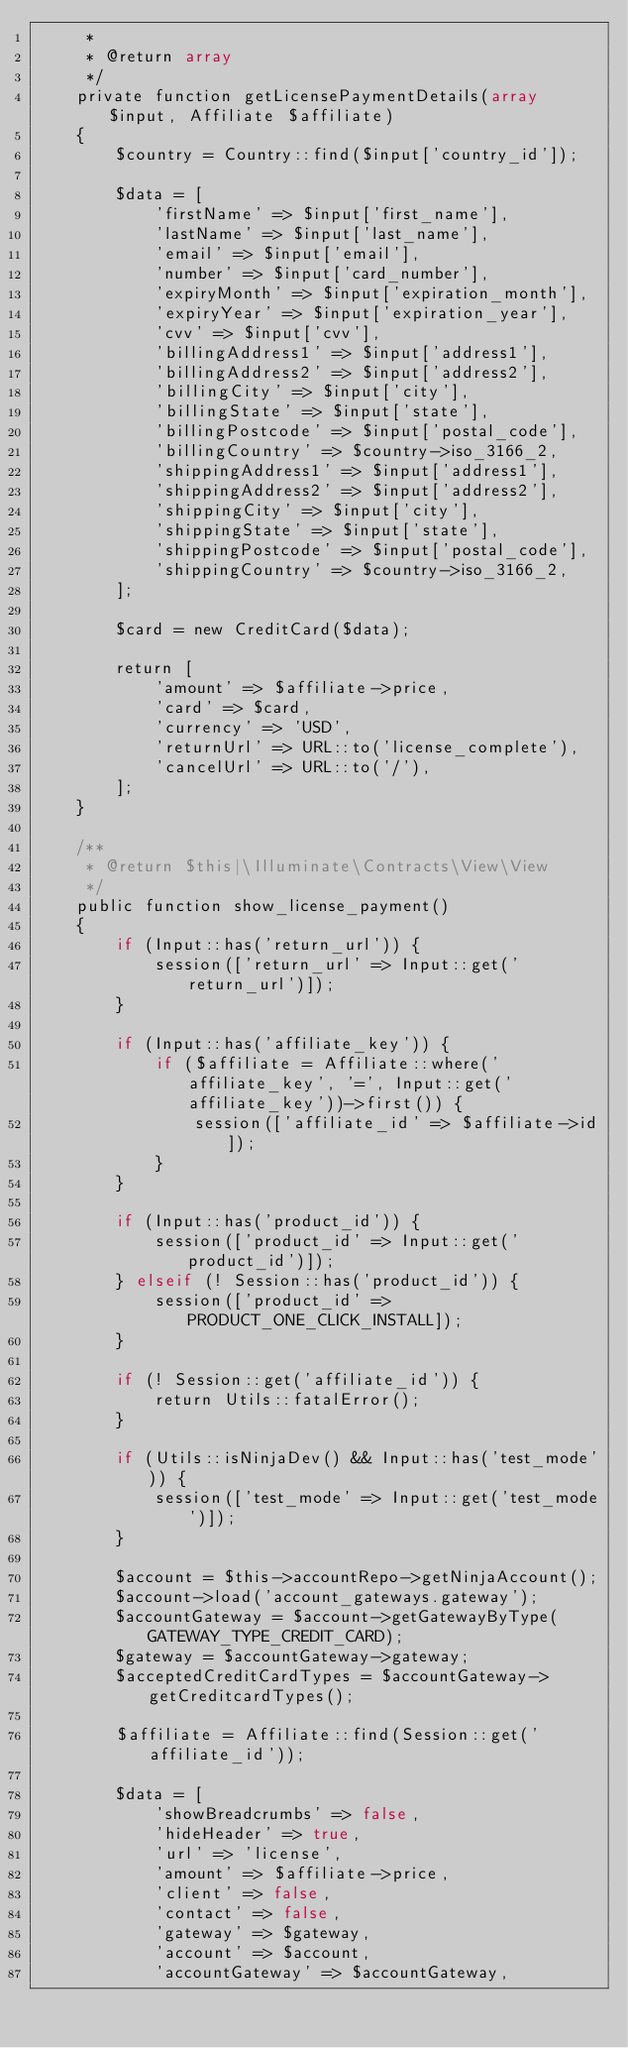Convert code to text. <code><loc_0><loc_0><loc_500><loc_500><_PHP_>     *
     * @return array
     */
    private function getLicensePaymentDetails(array $input, Affiliate $affiliate)
    {
        $country = Country::find($input['country_id']);

        $data = [
            'firstName' => $input['first_name'],
            'lastName' => $input['last_name'],
            'email' => $input['email'],
            'number' => $input['card_number'],
            'expiryMonth' => $input['expiration_month'],
            'expiryYear' => $input['expiration_year'],
            'cvv' => $input['cvv'],
            'billingAddress1' => $input['address1'],
            'billingAddress2' => $input['address2'],
            'billingCity' => $input['city'],
            'billingState' => $input['state'],
            'billingPostcode' => $input['postal_code'],
            'billingCountry' => $country->iso_3166_2,
            'shippingAddress1' => $input['address1'],
            'shippingAddress2' => $input['address2'],
            'shippingCity' => $input['city'],
            'shippingState' => $input['state'],
            'shippingPostcode' => $input['postal_code'],
            'shippingCountry' => $country->iso_3166_2,
        ];

        $card = new CreditCard($data);

        return [
            'amount' => $affiliate->price,
            'card' => $card,
            'currency' => 'USD',
            'returnUrl' => URL::to('license_complete'),
            'cancelUrl' => URL::to('/'),
        ];
    }

    /**
     * @return $this|\Illuminate\Contracts\View\View
     */
    public function show_license_payment()
    {
        if (Input::has('return_url')) {
            session(['return_url' => Input::get('return_url')]);
        }

        if (Input::has('affiliate_key')) {
            if ($affiliate = Affiliate::where('affiliate_key', '=', Input::get('affiliate_key'))->first()) {
                session(['affiliate_id' => $affiliate->id]);
            }
        }

        if (Input::has('product_id')) {
            session(['product_id' => Input::get('product_id')]);
        } elseif (! Session::has('product_id')) {
            session(['product_id' => PRODUCT_ONE_CLICK_INSTALL]);
        }

        if (! Session::get('affiliate_id')) {
            return Utils::fatalError();
        }

        if (Utils::isNinjaDev() && Input::has('test_mode')) {
            session(['test_mode' => Input::get('test_mode')]);
        }

        $account = $this->accountRepo->getNinjaAccount();
        $account->load('account_gateways.gateway');
        $accountGateway = $account->getGatewayByType(GATEWAY_TYPE_CREDIT_CARD);
        $gateway = $accountGateway->gateway;
        $acceptedCreditCardTypes = $accountGateway->getCreditcardTypes();

        $affiliate = Affiliate::find(Session::get('affiliate_id'));

        $data = [
            'showBreadcrumbs' => false,
            'hideHeader' => true,
            'url' => 'license',
            'amount' => $affiliate->price,
            'client' => false,
            'contact' => false,
            'gateway' => $gateway,
            'account' => $account,
            'accountGateway' => $accountGateway,</code> 